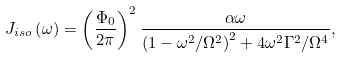Convert formula to latex. <formula><loc_0><loc_0><loc_500><loc_500>J _ { i s o } \left ( \omega \right ) = \left ( \frac { \Phi _ { 0 } } { 2 \pi } \right ) ^ { 2 } \frac { \alpha \omega } { \left ( 1 - \omega ^ { 2 } / \Omega ^ { 2 } \right ) ^ { 2 } + 4 \omega ^ { 2 } \Gamma ^ { 2 } / \Omega ^ { 4 } } ,</formula> 